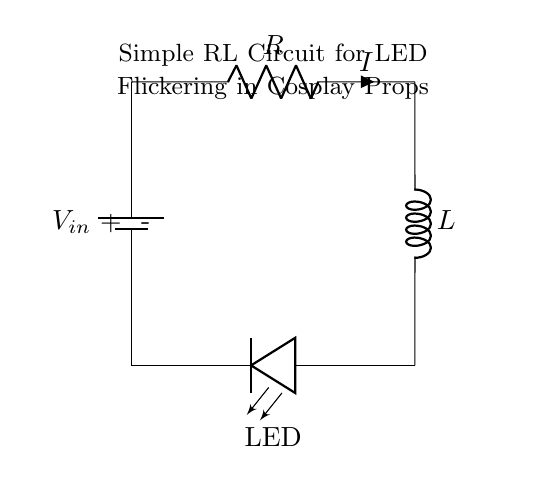What is the component at the top of the circuit? The component at the top is a battery, which supplies the voltage to the circuit.
Answer: battery What does the resistor do in the circuit? The resistor limits the current flowing to the LED, preventing it from burning out due to excessive current.
Answer: limits current What is the value of the current indicated in the circuit? The current is indicated with 'I' in the diagram; however, no numeric value is provided directly in the visual.
Answer: I Which component creates the flickering effect for the LED? The inductor creates the flickering effect by storing energy and releasing it in bursts, which causes the LED to flicker.
Answer: inductor How does the orientation of the LED affect its function? The LED must be oriented correctly; if reversed, it will not light up since it is a diode that only allows current to flow in one direction.
Answer: orientation matters What type of circuit is represented by this diagram? This circuit is a simple RL circuit, combining a resistor and inductor, configured to drive an LED for flickering effects.
Answer: RL circuit 